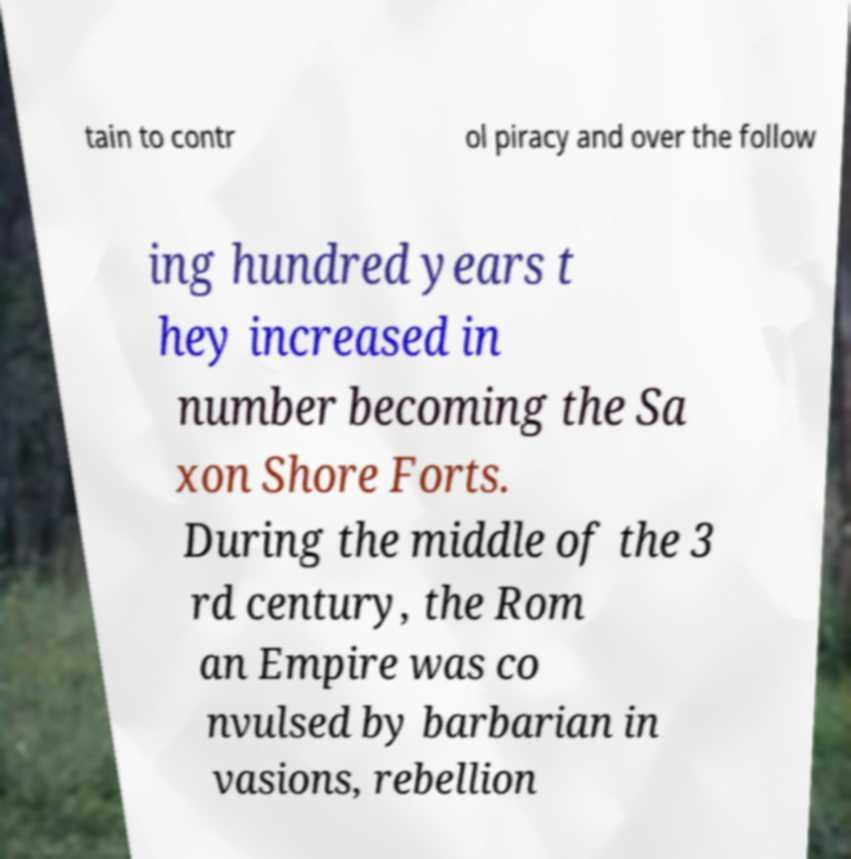Could you assist in decoding the text presented in this image and type it out clearly? tain to contr ol piracy and over the follow ing hundred years t hey increased in number becoming the Sa xon Shore Forts. During the middle of the 3 rd century, the Rom an Empire was co nvulsed by barbarian in vasions, rebellion 